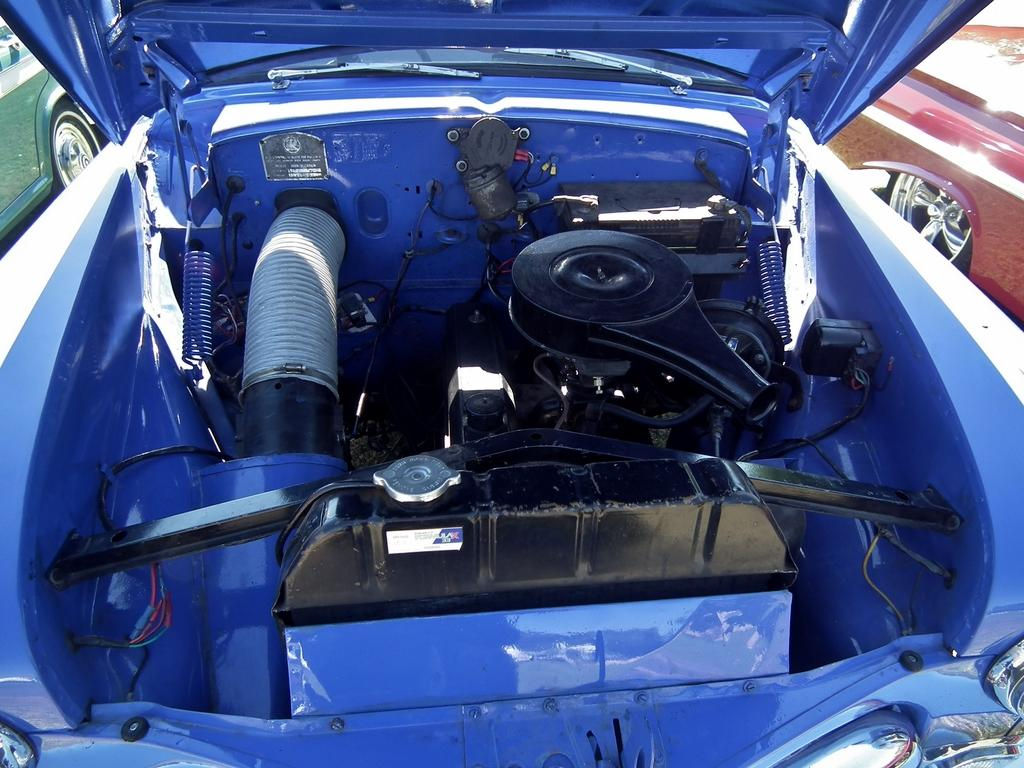How many cars are visible in the image? There are three cars in the image. Can you describe the location of the green car in the image? The green car is on the left side of the image. Where is the red car located in the image? The red car is on the right side of the image. What color is the car in the center of the image? The car in the center of the image is blue. What type of corn is growing on the roof of the green car in the image? There is no corn present in the image, and the green car does not have a roof. 